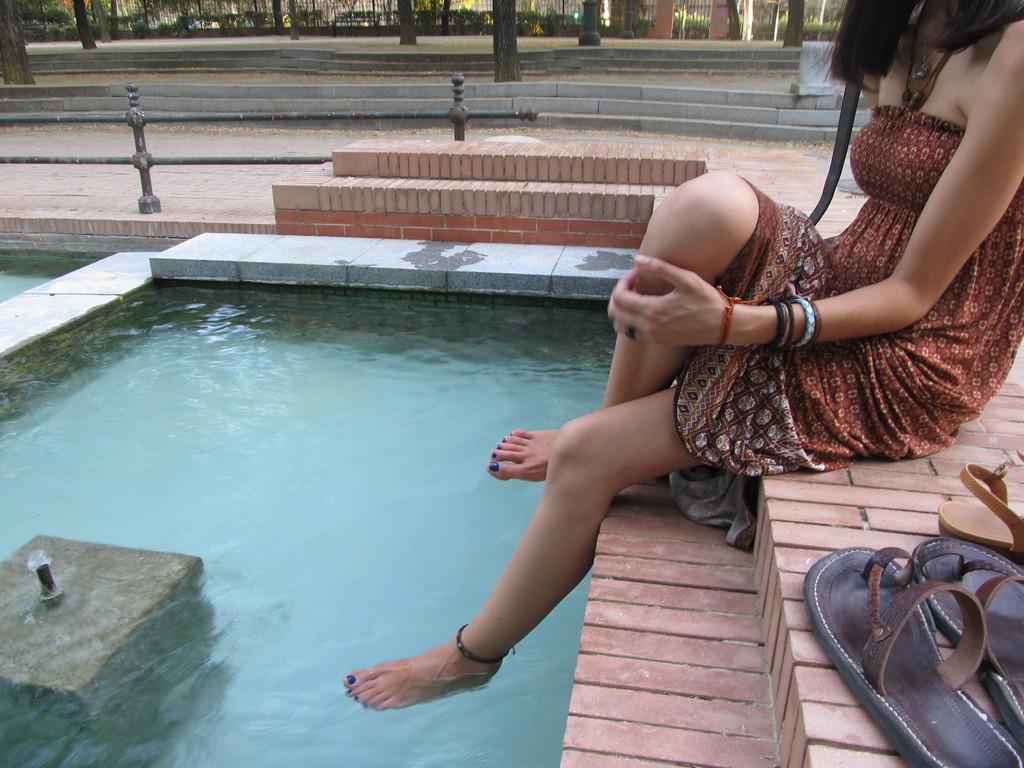How would you summarize this image in a sentence or two? In the image there is girl sitting above pool with legs in it, on the right side there are flippers on the floor, on the left side there is fence, behind it there are trees on either side of the road. 